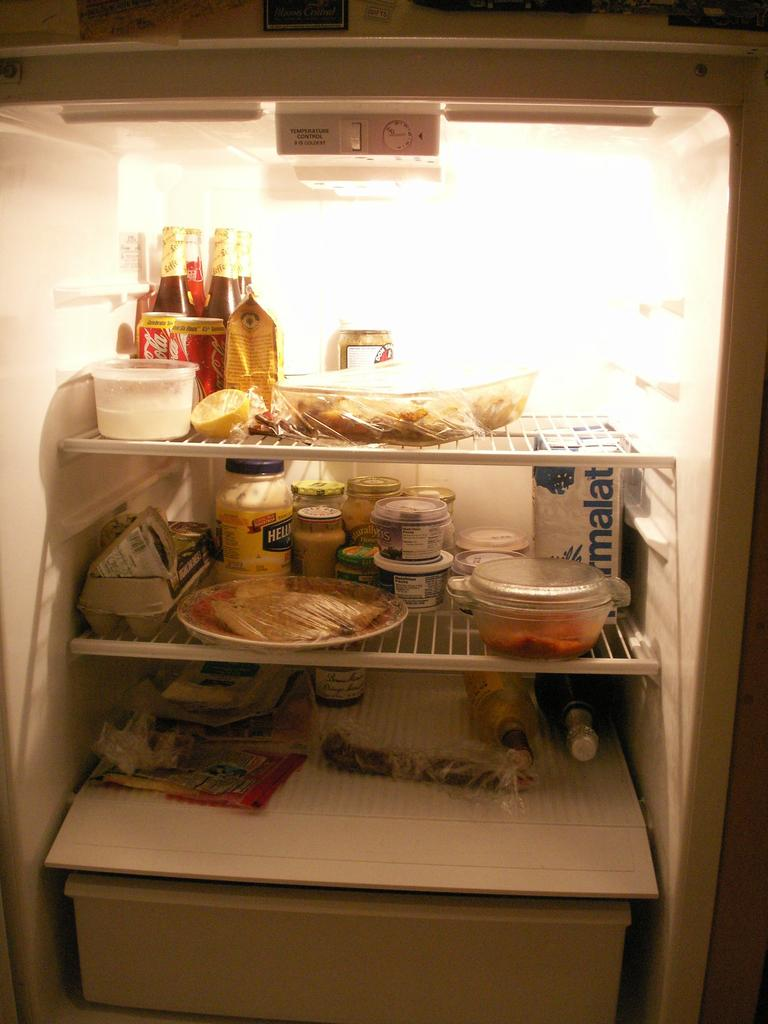<image>
Present a compact description of the photo's key features. A refrigerator is full with food and drinks such as Coca-Cola and Hellman's Mayo. 